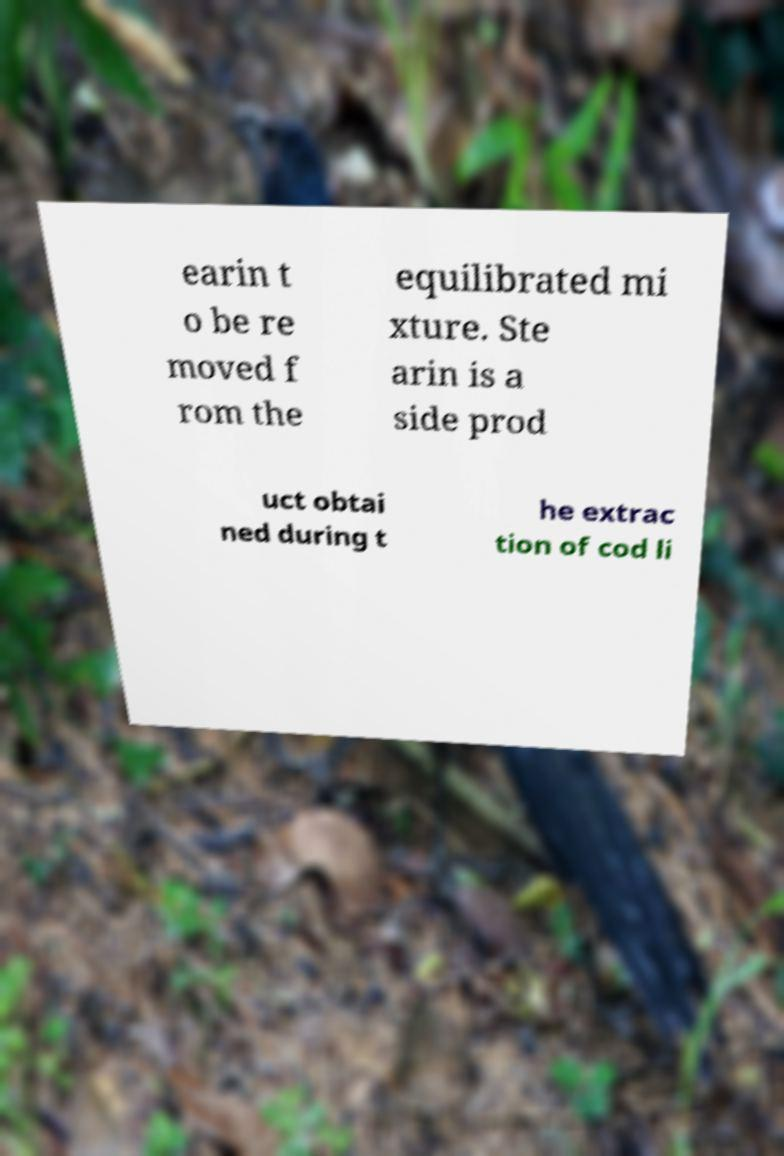Please identify and transcribe the text found in this image. earin t o be re moved f rom the equilibrated mi xture. Ste arin is a side prod uct obtai ned during t he extrac tion of cod li 